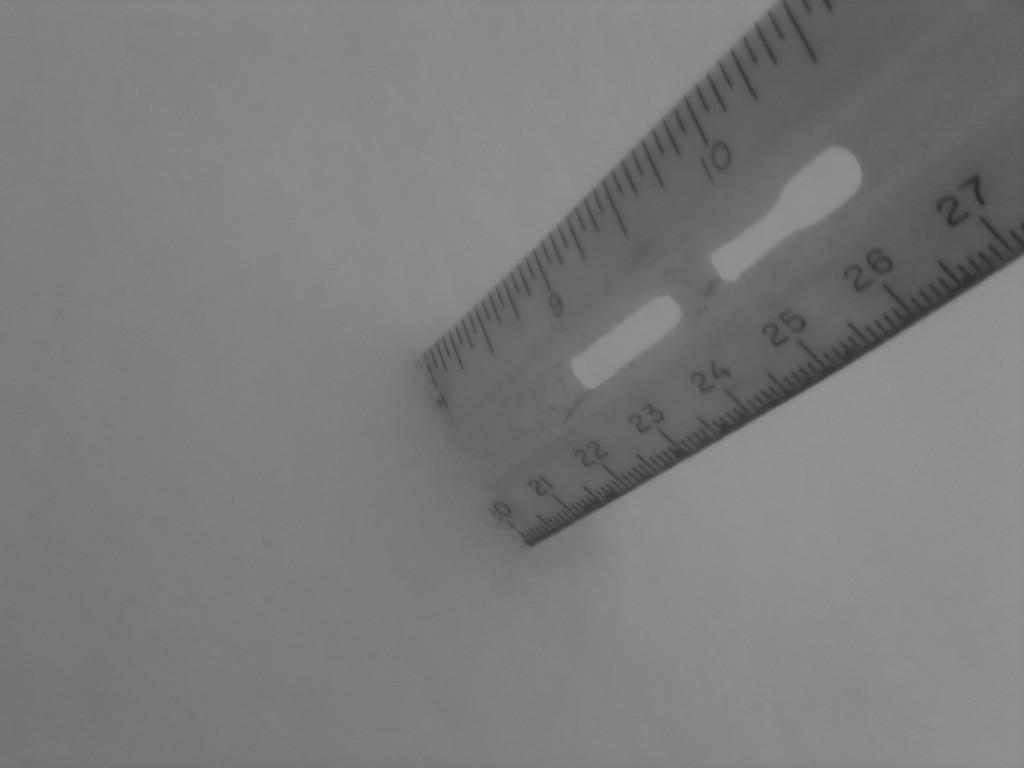<image>
Render a clear and concise summary of the photo. the number 25 is on the white ruler 